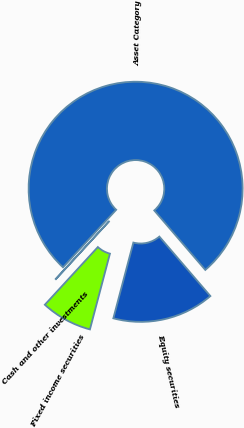Convert chart to OTSL. <chart><loc_0><loc_0><loc_500><loc_500><pie_chart><fcel>Asset Category<fcel>Equity securities<fcel>Fixed income securities<fcel>Cash and other investments<nl><fcel>76.84%<fcel>15.4%<fcel>7.72%<fcel>0.04%<nl></chart> 